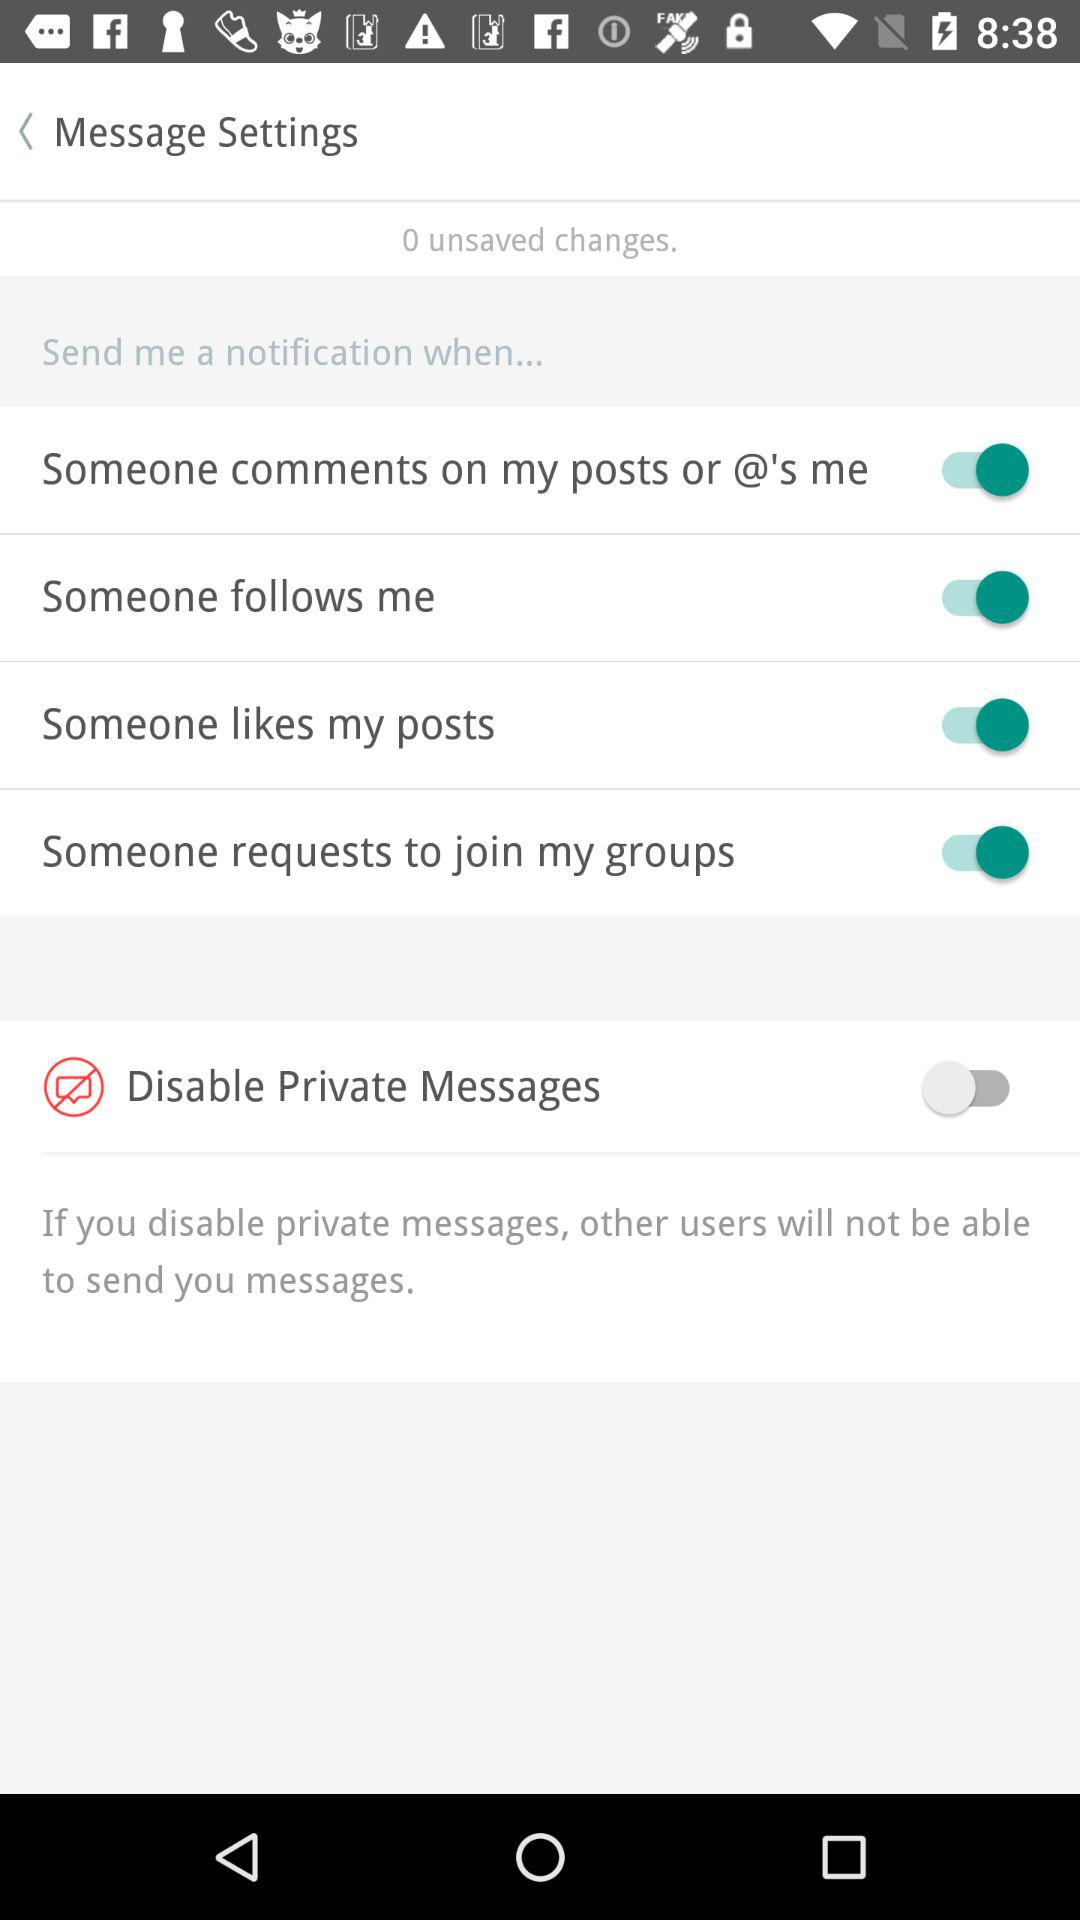How many changes are unsaved? The unsaved changes are 0. 